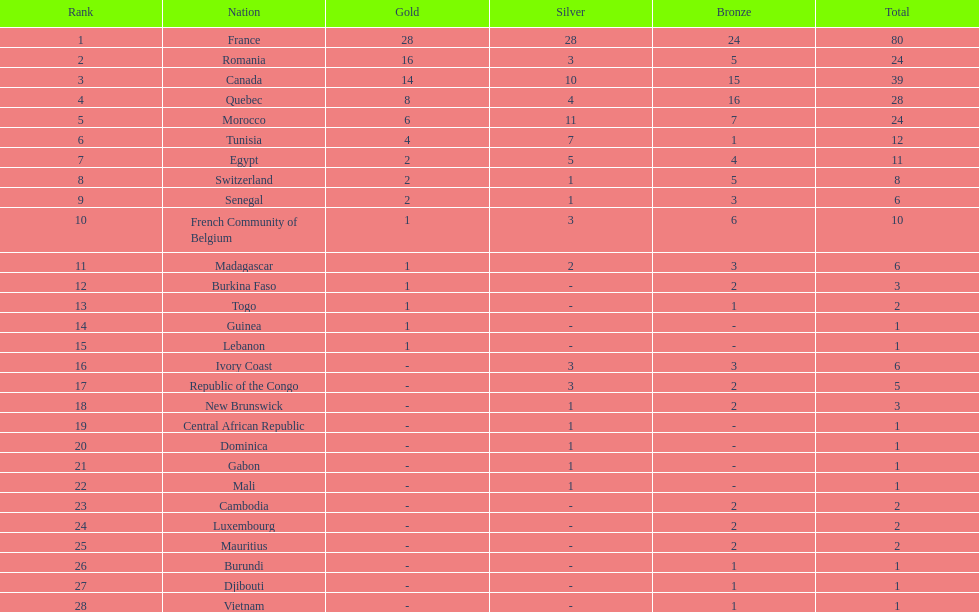What is the difference between france's and egypt's silver medals? 23. 